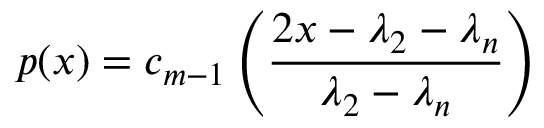Convert formula to latex. <formula><loc_0><loc_0><loc_500><loc_500>p ( x ) = c _ { m - 1 } \left ( { \frac { 2 x - \lambda _ { 2 } - \lambda _ { n } } { \lambda _ { 2 } - \lambda _ { n } } } \right )</formula> 